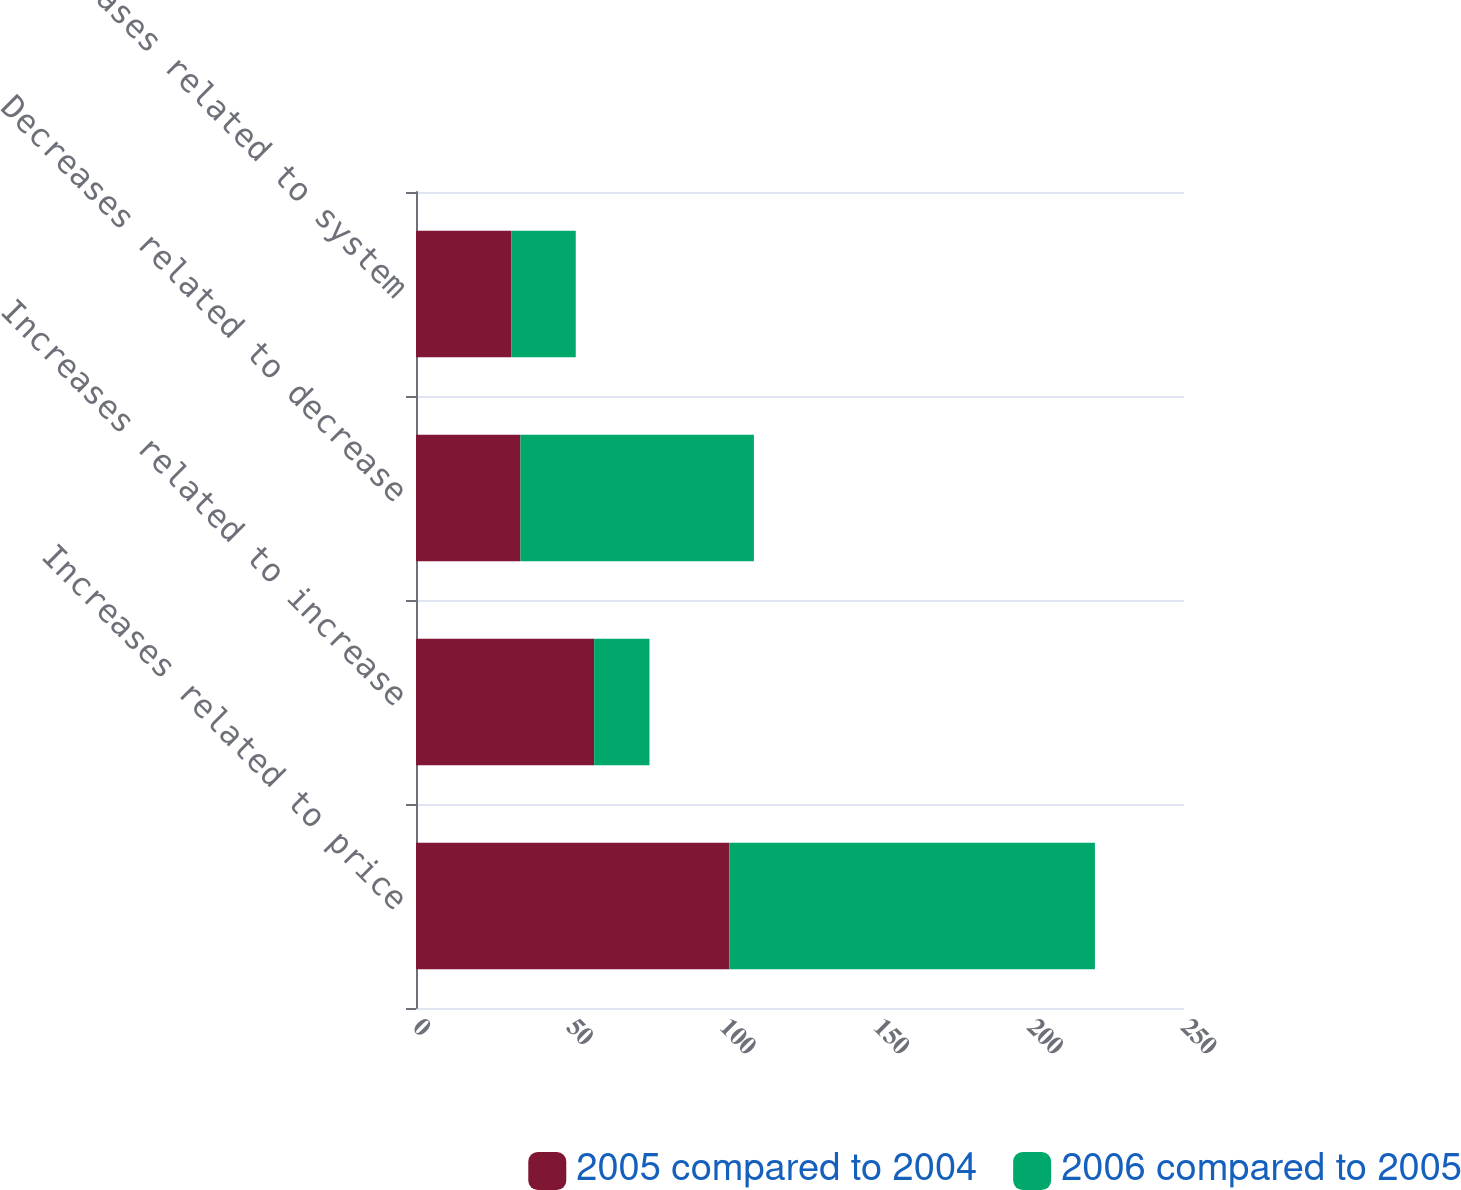Convert chart. <chart><loc_0><loc_0><loc_500><loc_500><stacked_bar_chart><ecel><fcel>Increases related to price<fcel>Increases related to increase<fcel>Decreases related to decrease<fcel>Decreases related to system<nl><fcel>2005 compared to 2004<fcel>102<fcel>58<fcel>34<fcel>31<nl><fcel>2006 compared to 2005<fcel>119<fcel>18<fcel>76<fcel>21<nl></chart> 